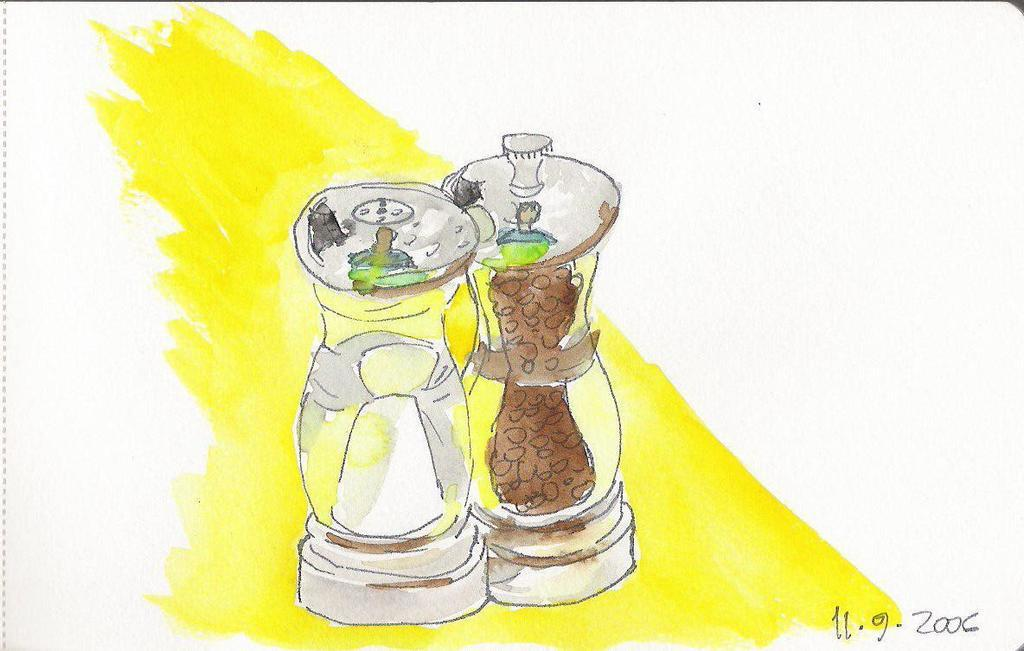<image>
Offer a succinct explanation of the picture presented. A painting of a salt and pepper set made on 11.9.2006. 